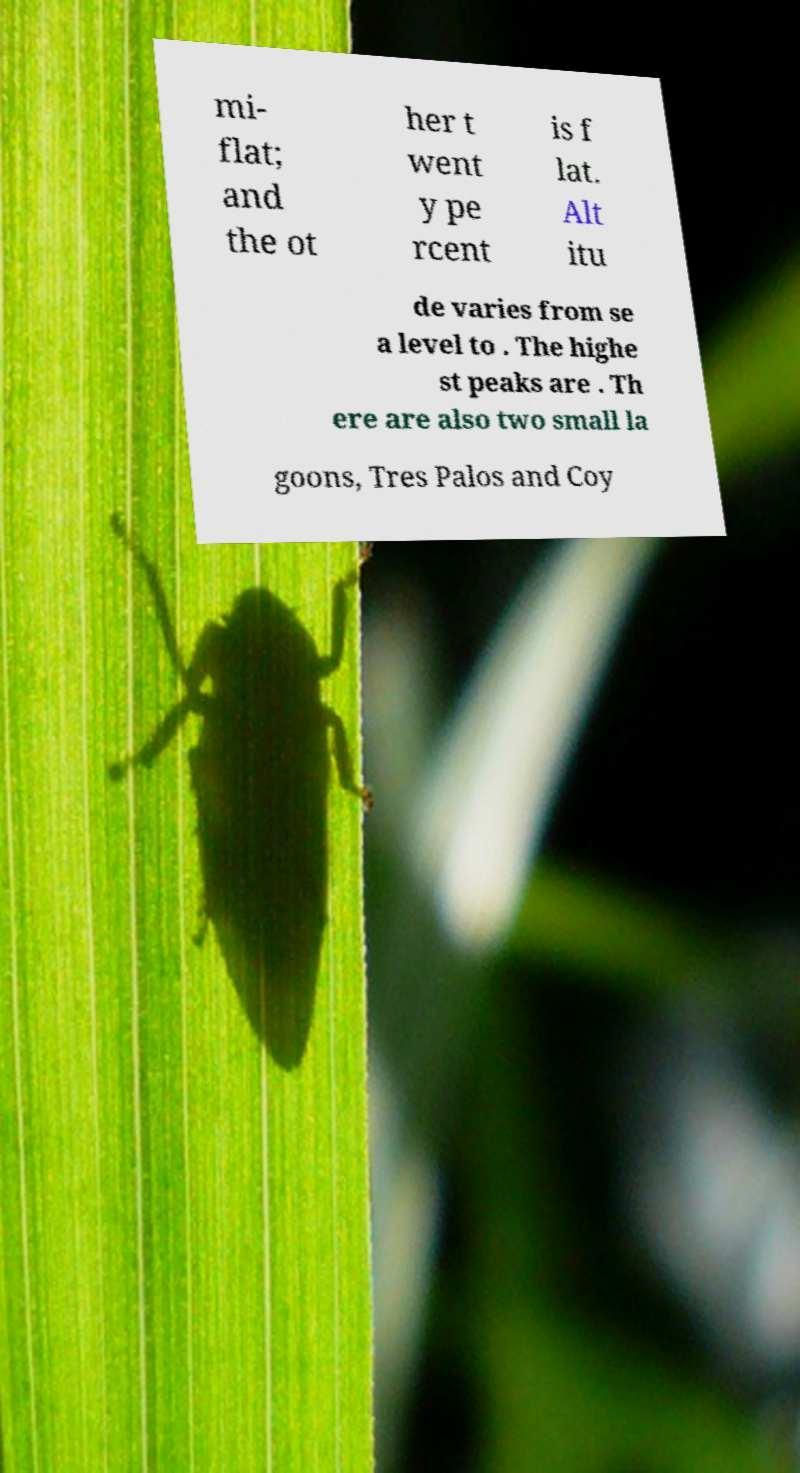What messages or text are displayed in this image? I need them in a readable, typed format. mi- flat; and the ot her t went y pe rcent is f lat. Alt itu de varies from se a level to . The highe st peaks are . Th ere are also two small la goons, Tres Palos and Coy 